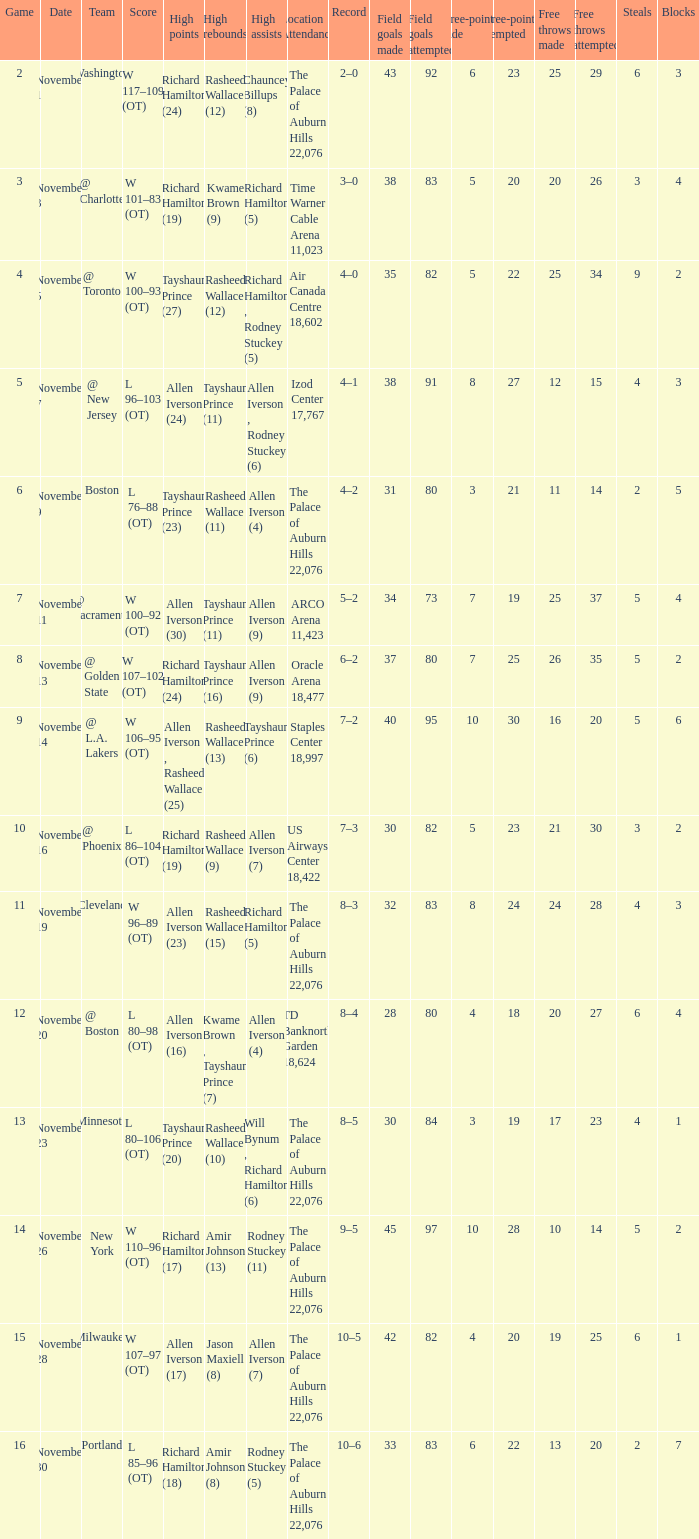What is Location Attendance, when High Points is "Allen Iverson (23)"? The Palace of Auburn Hills 22,076. Can you parse all the data within this table? {'header': ['Game', 'Date', 'Team', 'Score', 'High points', 'High rebounds', 'High assists', 'Location Attendance', 'Record', 'Field goals made', 'Field goals attempted', 'Three-pointers made', 'Three-pointers attempted', 'Free throws made', 'Free throws attempted', 'Steals', 'Blocks'], 'rows': [['2', 'November 1', 'Washington', 'W 117–109 (OT)', 'Richard Hamilton (24)', 'Rasheed Wallace (12)', 'Chauncey Billups (8)', 'The Palace of Auburn Hills 22,076', '2–0', '43', '92', '6', '23', '25', '29', '6', '3'], ['3', 'November 3', '@ Charlotte', 'W 101–83 (OT)', 'Richard Hamilton (19)', 'Kwame Brown (9)', 'Richard Hamilton (5)', 'Time Warner Cable Arena 11,023', '3–0', '38', '83', '5', '20', '20', '26', '3', '4'], ['4', 'November 5', '@ Toronto', 'W 100–93 (OT)', 'Tayshaun Prince (27)', 'Rasheed Wallace (12)', 'Richard Hamilton , Rodney Stuckey (5)', 'Air Canada Centre 18,602', '4–0', '35', '82', '5', '22', '25', '34', '9', '2'], ['5', 'November 7', '@ New Jersey', 'L 96–103 (OT)', 'Allen Iverson (24)', 'Tayshaun Prince (11)', 'Allen Iverson , Rodney Stuckey (6)', 'Izod Center 17,767', '4–1', '38', '91', '8', '27', '12', '15', '4', '3'], ['6', 'November 9', 'Boston', 'L 76–88 (OT)', 'Tayshaun Prince (23)', 'Rasheed Wallace (11)', 'Allen Iverson (4)', 'The Palace of Auburn Hills 22,076', '4–2', '31', '80', '3', '21', '11', '14', '2', '5'], ['7', 'November 11', '@ Sacramento', 'W 100–92 (OT)', 'Allen Iverson (30)', 'Tayshaun Prince (11)', 'Allen Iverson (9)', 'ARCO Arena 11,423', '5–2', '34', '73', '7', '19', '25', '37', '5', '4'], ['8', 'November 13', '@ Golden State', 'W 107–102 (OT)', 'Richard Hamilton (24)', 'Tayshaun Prince (16)', 'Allen Iverson (9)', 'Oracle Arena 18,477', '6–2', '37', '80', '7', '25', '26', '35', '5', '2'], ['9', 'November 14', '@ L.A. Lakers', 'W 106–95 (OT)', 'Allen Iverson , Rasheed Wallace (25)', 'Rasheed Wallace (13)', 'Tayshaun Prince (6)', 'Staples Center 18,997', '7–2', '40', '95', '10', '30', '16', '20', '5', '6'], ['10', 'November 16', '@ Phoenix', 'L 86–104 (OT)', 'Richard Hamilton (19)', 'Rasheed Wallace (9)', 'Allen Iverson (7)', 'US Airways Center 18,422', '7–3', '30', '82', '5', '23', '21', '30', '3', '2'], ['11', 'November 19', 'Cleveland', 'W 96–89 (OT)', 'Allen Iverson (23)', 'Rasheed Wallace (15)', 'Richard Hamilton (5)', 'The Palace of Auburn Hills 22,076', '8–3', '32', '83', '8', '24', '24', '28', '4', '3'], ['12', 'November 20', '@ Boston', 'L 80–98 (OT)', 'Allen Iverson (16)', 'Kwame Brown , Tayshaun Prince (7)', 'Allen Iverson (4)', 'TD Banknorth Garden 18,624', '8–4', '28', '80', '4', '18', '20', '27', '6', '4'], ['13', 'November 23', 'Minnesota', 'L 80–106 (OT)', 'Tayshaun Prince (20)', 'Rasheed Wallace (10)', 'Will Bynum , Richard Hamilton (6)', 'The Palace of Auburn Hills 22,076', '8–5', '30', '84', '3', '19', '17', '23', '4', '1'], ['14', 'November 26', 'New York', 'W 110–96 (OT)', 'Richard Hamilton (17)', 'Amir Johnson (13)', 'Rodney Stuckey (11)', 'The Palace of Auburn Hills 22,076', '9–5', '45', '97', '10', '28', '10', '14', '5', '2'], ['15', 'November 28', 'Milwaukee', 'W 107–97 (OT)', 'Allen Iverson (17)', 'Jason Maxiell (8)', 'Allen Iverson (7)', 'The Palace of Auburn Hills 22,076', '10–5', '42', '82', '4', '20', '19', '25', '6', '1'], ['16', 'November 30', 'Portland', 'L 85–96 (OT)', 'Richard Hamilton (18)', 'Amir Johnson (8)', 'Rodney Stuckey (5)', 'The Palace of Auburn Hills 22,076', '10–6', '33', '83', '6', '22', '13', '20', '2', '7']]} 